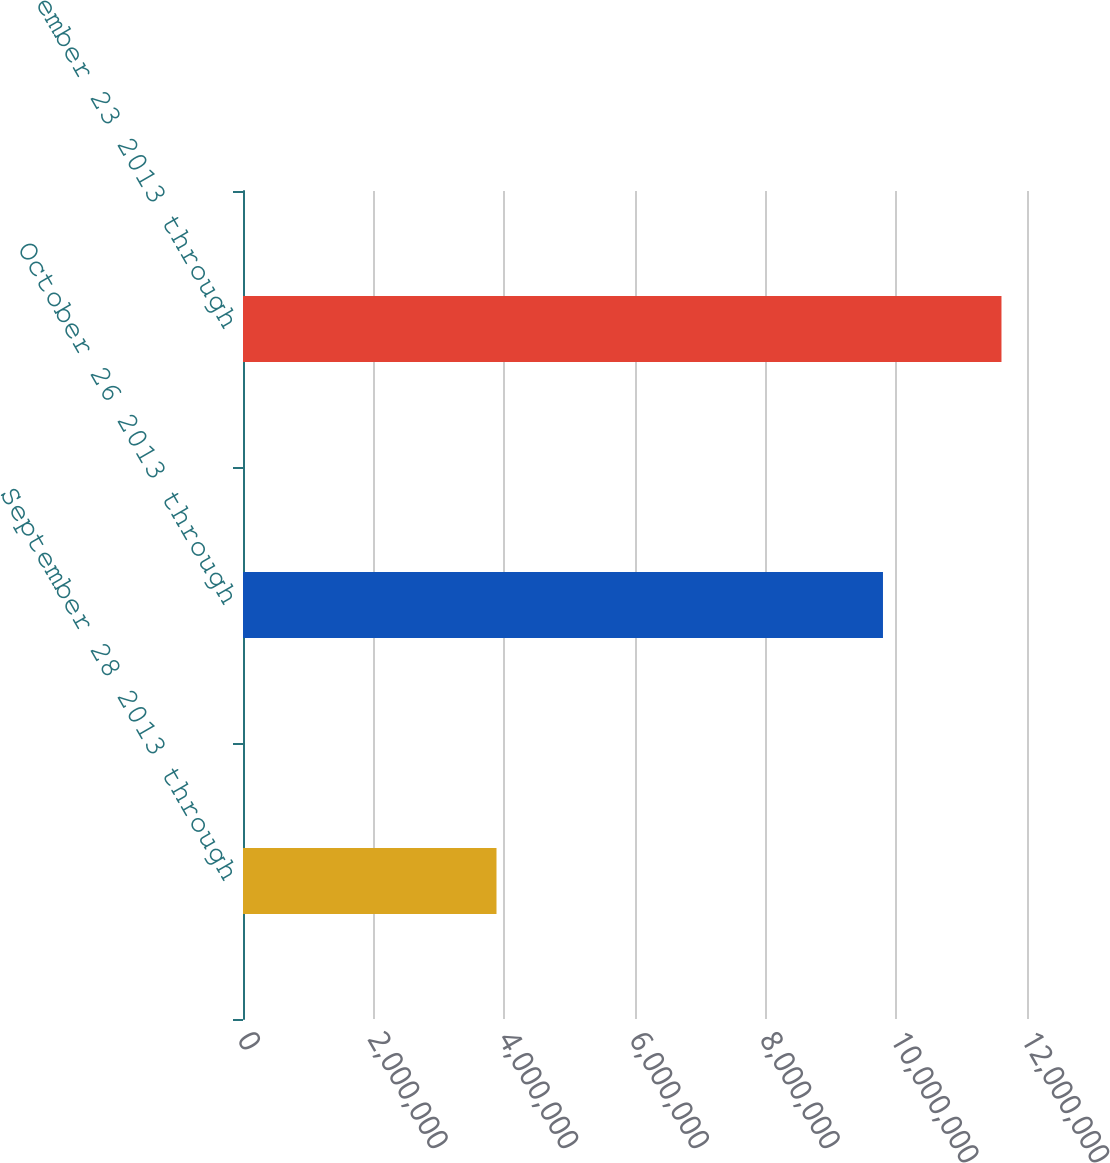Convert chart. <chart><loc_0><loc_0><loc_500><loc_500><bar_chart><fcel>September 28 2013 through<fcel>October 26 2013 through<fcel>November 23 2013 through<nl><fcel>3.88e+06<fcel>9.7955e+06<fcel>1.16093e+07<nl></chart> 